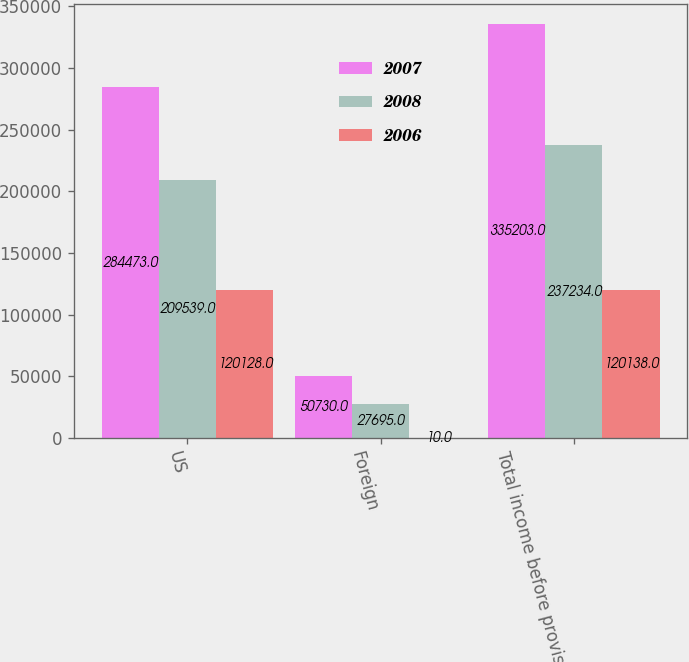<chart> <loc_0><loc_0><loc_500><loc_500><stacked_bar_chart><ecel><fcel>US<fcel>Foreign<fcel>Total income before provision<nl><fcel>2007<fcel>284473<fcel>50730<fcel>335203<nl><fcel>2008<fcel>209539<fcel>27695<fcel>237234<nl><fcel>2006<fcel>120128<fcel>10<fcel>120138<nl></chart> 